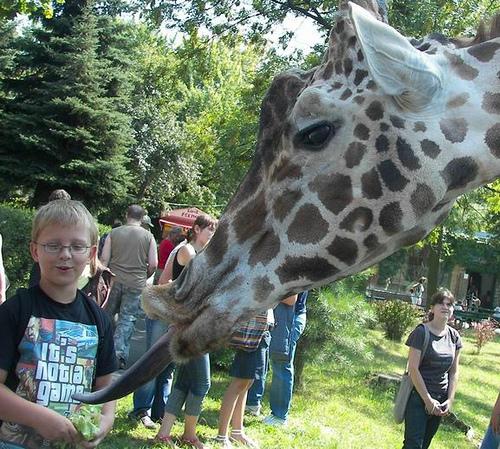How many people are feeding animals?
Short answer required. 1. Is this animal in captivity?
Quick response, please. Yes. What is the t-shirt advertising?
Keep it brief. Grand theft auto. Is the giraffe's mouth closed?
Short answer required. No. What is reaching out to touch the shirt?
Short answer required. Tongue. 